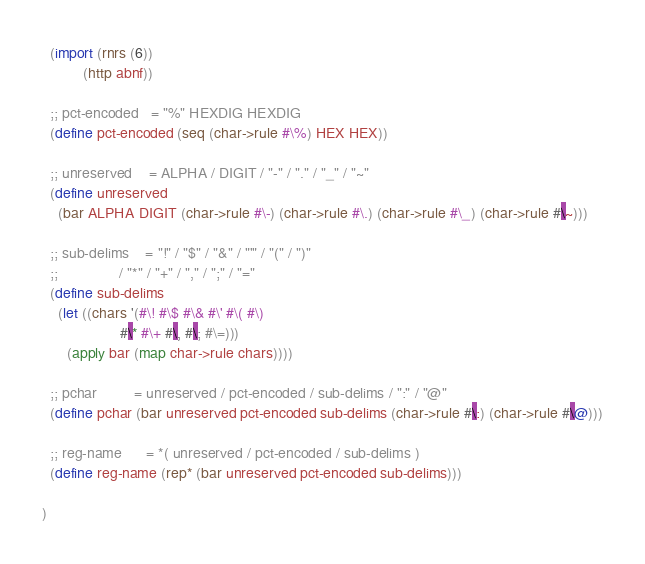Convert code to text. <code><loc_0><loc_0><loc_500><loc_500><_Scheme_>  (import (rnrs (6))
          (http abnf))

  ;; pct-encoded   = "%" HEXDIG HEXDIG
  (define pct-encoded (seq (char->rule #\%) HEX HEX))

  ;; unreserved    = ALPHA / DIGIT / "-" / "." / "_" / "~"
  (define unreserved
    (bar ALPHA DIGIT (char->rule #\-) (char->rule #\.) (char->rule #\_) (char->rule #\~)))

  ;; sub-delims    = "!" / "$" / "&" / "'" / "(" / ")"
  ;;               / "*" / "+" / "," / ";" / "="
  (define sub-delims
    (let ((chars '(#\! #\$ #\& #\' #\( #\)
                   #\* #\+ #\, #\; #\=)))
      (apply bar (map char->rule chars))))

  ;; pchar         = unreserved / pct-encoded / sub-delims / ":" / "@"
  (define pchar (bar unreserved pct-encoded sub-delims (char->rule #\:) (char->rule #\@)))

  ;; reg-name      = *( unreserved / pct-encoded / sub-delims )
  (define reg-name (rep* (bar unreserved pct-encoded sub-delims)))

)
</code> 